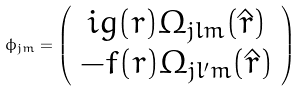<formula> <loc_0><loc_0><loc_500><loc_500>\phi _ { j m } = \left ( \begin{array} { c c c c c } i g ( r ) \Omega _ { j l m } ( \hat { r } ) \\ - f ( r ) \Omega _ { j l ^ { \prime } m } ( \hat { r } ) \end{array} \right )</formula> 